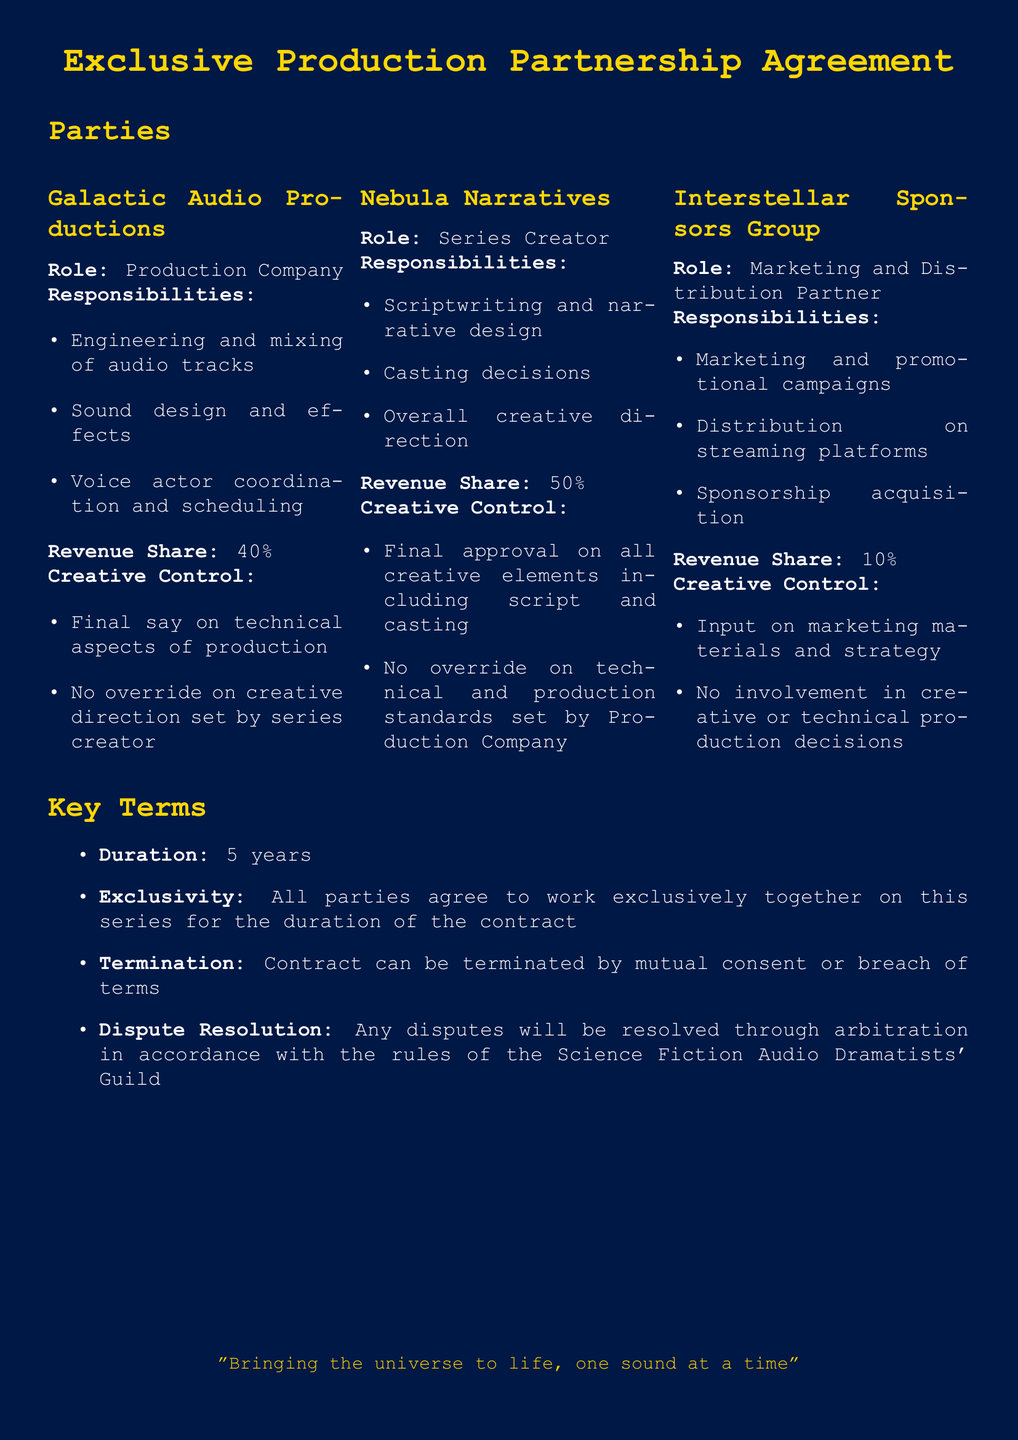What is the name of the production company? The production company involved in the agreement is named "Galactic Audio Productions".
Answer: Galactic Audio Productions What is the revenue share for the series creator? The revenue share allocated to the series creator, Nebula Narratives, is specified in the document.
Answer: 50% What is the duration of the contract? The duration of the contract is clearly stated in the document.
Answer: 5 years Which party has the final say on technical aspects of production? The document specifies that Galactic Audio Productions has the final say on technical aspects of production.
Answer: Galactic Audio Productions What aspect does the Interstellar Sponsors Group control? The Interstellar Sponsors Group has input on marketing materials and strategy according to the document.
Answer: Marketing materials and strategy Who is responsible for scriptwriting and narrative design? The document lists the series creator as responsible for scriptwriting and narrative design.
Answer: Nebula Narratives What can terminate the contract? The document mentions two conditions that can lead to the termination of the contract.
Answer: Mutual consent or breach of terms What is the marketing partner's revenue share? The revenue share for Interstellar Sponsors Group is specified in the document.
Answer: 10% Which guild governs dispute resolution? The document states that disputes will be resolved in accordance with the rules of a specific guild.
Answer: Science Fiction Audio Dramatists' Guild 